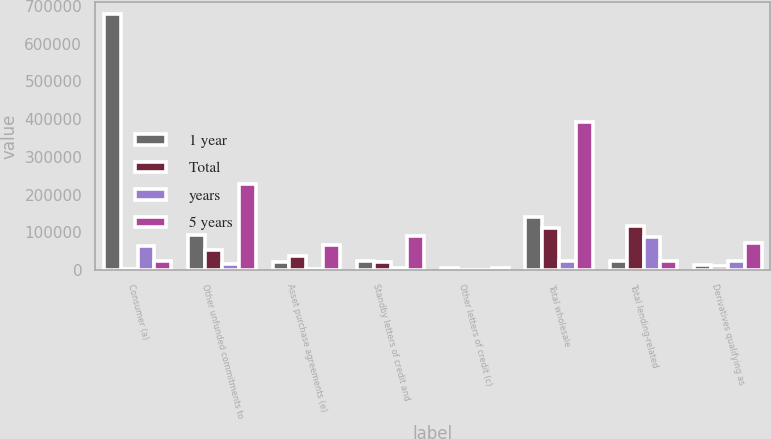Convert chart to OTSL. <chart><loc_0><loc_0><loc_500><loc_500><stacked_bar_chart><ecel><fcel>Consumer (a)<fcel>Other unfunded commitments to<fcel>Asset purchase agreements (e)<fcel>Standby letters of credit and<fcel>Other letters of credit (c)<fcel>Total wholesale<fcel>Total lending-related<fcel>Derivatives qualifying as<nl><fcel>1 year<fcel>677784<fcel>92829<fcel>20847<fcel>23264<fcel>4628<fcel>141568<fcel>23862<fcel>13542<nl><fcel>Total<fcel>3807<fcel>52465<fcel>38071<fcel>21286<fcel>823<fcel>112645<fcel>116452<fcel>10656<nl><fcel>years<fcel>62340<fcel>16660<fcel>1425<fcel>5770<fcel>7<fcel>23862<fcel>86202<fcel>22919<nl><fcel>5 years<fcel>23862<fcel>229204<fcel>67529<fcel>89132<fcel>5559<fcel>391424<fcel>23862<fcel>71531<nl></chart> 